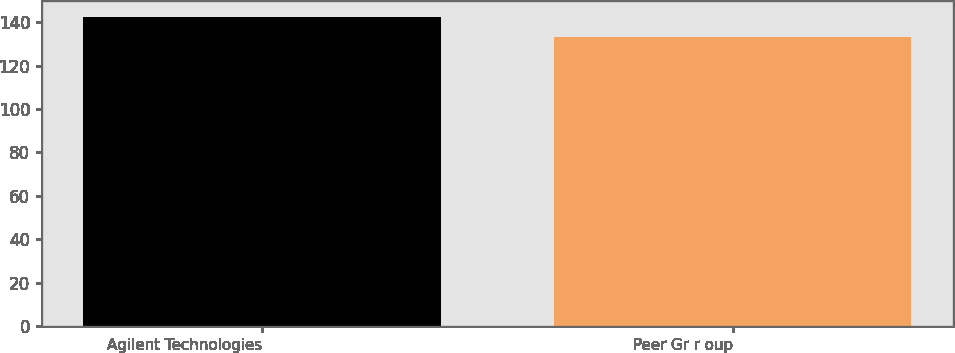<chart> <loc_0><loc_0><loc_500><loc_500><bar_chart><fcel>Agilent Technologies<fcel>Peer Gr r oup<nl><fcel>142.52<fcel>133<nl></chart> 